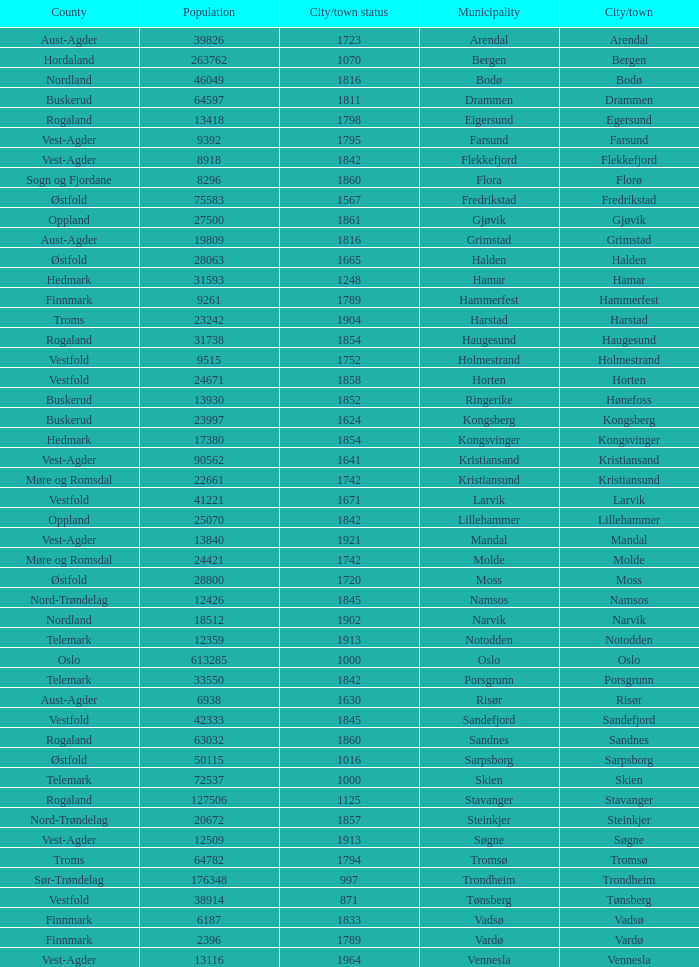What are the cities/towns located in the municipality of Horten? Horten. 